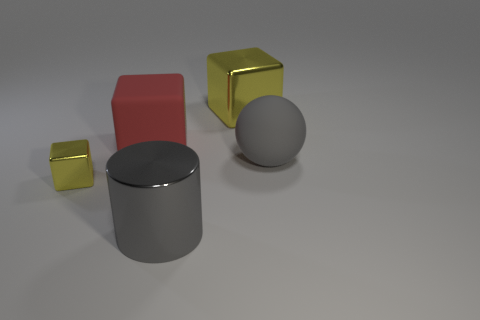How many tiny purple shiny objects have the same shape as the red thing?
Your answer should be very brief. 0. There is a yellow object that is on the left side of the gray cylinder; what is its material?
Ensure brevity in your answer.  Metal. There is a matte thing that is left of the big rubber sphere; is it the same shape as the small yellow metallic thing?
Your answer should be very brief. Yes. Is there a yellow cube that has the same size as the red matte cube?
Give a very brief answer. Yes. Is the shape of the small thing the same as the big gray thing that is in front of the tiny block?
Offer a very short reply. No. The large metallic object that is the same color as the tiny metallic thing is what shape?
Make the answer very short. Cube. Is the number of metallic cubes left of the large shiny cube less than the number of big gray balls?
Offer a very short reply. No. Is the shape of the small metal thing the same as the large gray rubber object?
Your answer should be very brief. No. What size is the red block that is the same material as the gray ball?
Offer a terse response. Large. Are there fewer red rubber objects than metallic cubes?
Offer a very short reply. Yes. 